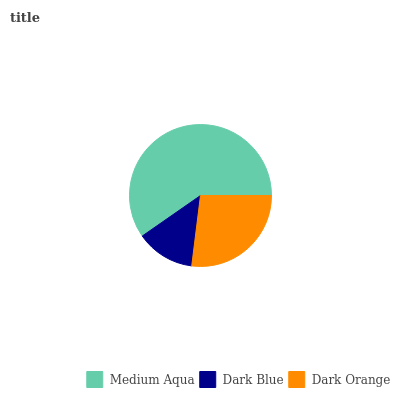Is Dark Blue the minimum?
Answer yes or no. Yes. Is Medium Aqua the maximum?
Answer yes or no. Yes. Is Dark Orange the minimum?
Answer yes or no. No. Is Dark Orange the maximum?
Answer yes or no. No. Is Dark Orange greater than Dark Blue?
Answer yes or no. Yes. Is Dark Blue less than Dark Orange?
Answer yes or no. Yes. Is Dark Blue greater than Dark Orange?
Answer yes or no. No. Is Dark Orange less than Dark Blue?
Answer yes or no. No. Is Dark Orange the high median?
Answer yes or no. Yes. Is Dark Orange the low median?
Answer yes or no. Yes. Is Medium Aqua the high median?
Answer yes or no. No. Is Medium Aqua the low median?
Answer yes or no. No. 